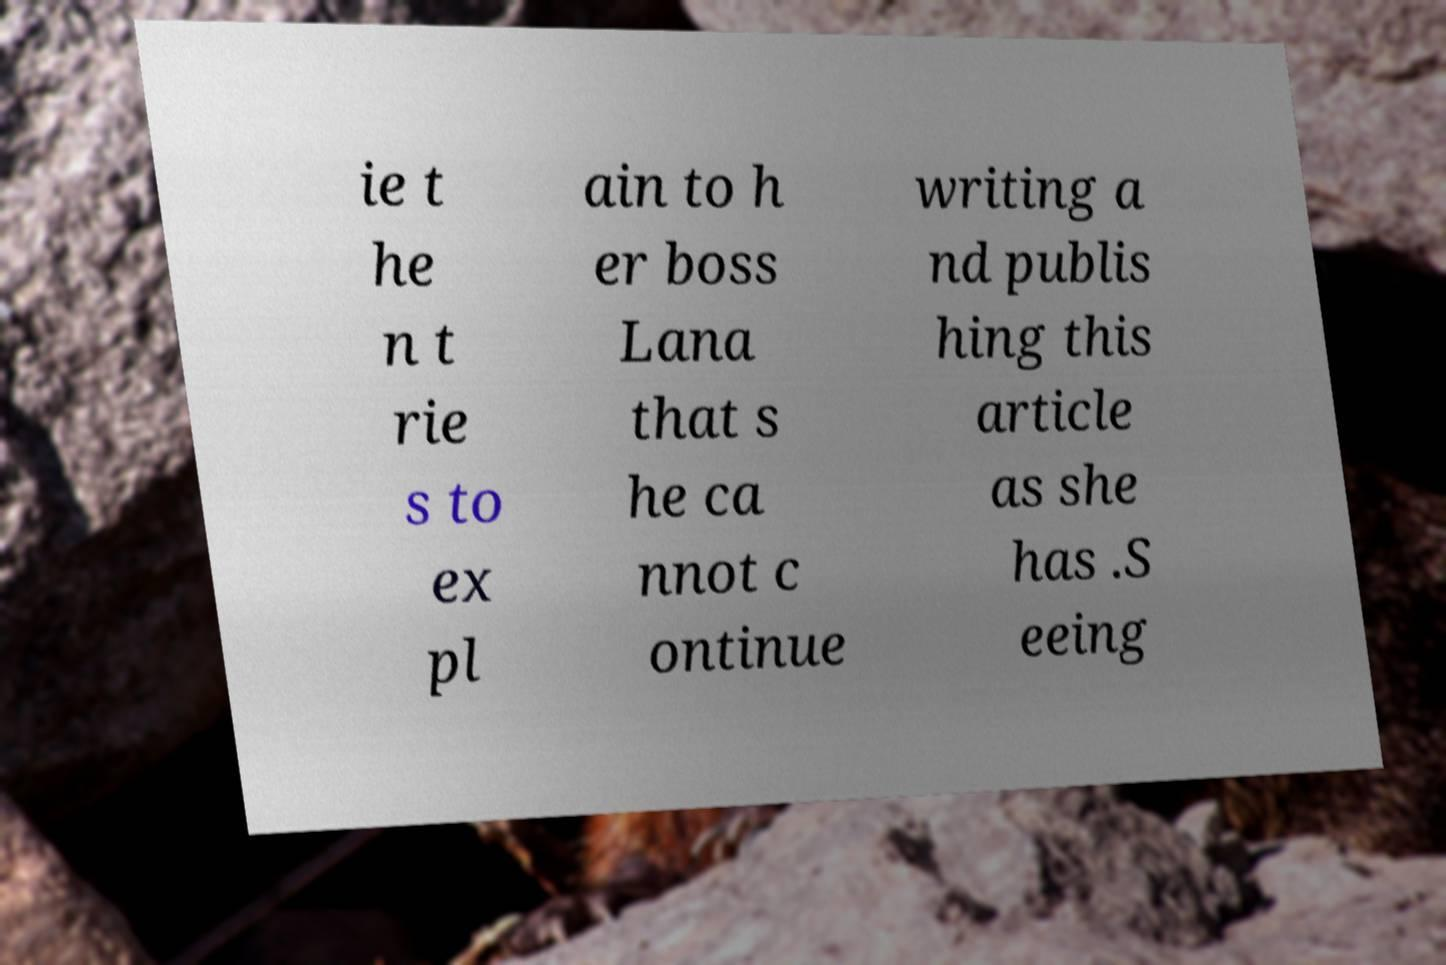Please read and relay the text visible in this image. What does it say? ie t he n t rie s to ex pl ain to h er boss Lana that s he ca nnot c ontinue writing a nd publis hing this article as she has .S eeing 